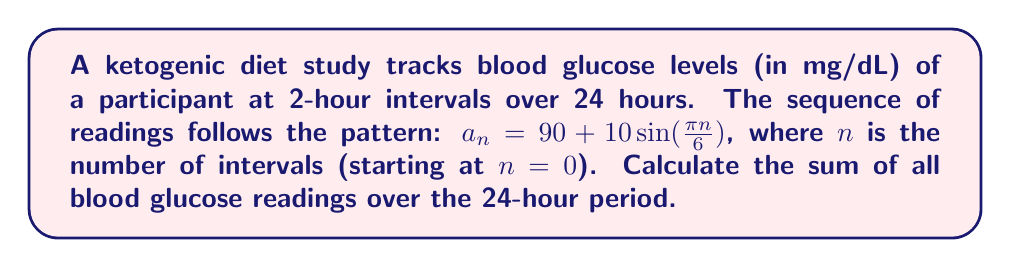Teach me how to tackle this problem. 1) First, we need to determine how many readings there are in 24 hours:
   24 hours / 2-hour intervals = 12 readings (plus the initial reading at n=0)
   So, we need to sum from n=0 to n=12

2) The formula for each reading is: $a_n = 90 + 10\sin(\frac{\pi n}{6})$

3) We need to calculate the sum: $\sum_{n=0}^{12} (90 + 10\sin(\frac{\pi n}{6}))$

4) This can be split into two sums:
   $\sum_{n=0}^{12} 90 + \sum_{n=0}^{12} 10\sin(\frac{\pi n}{6})$

5) The first sum is straightforward:
   $\sum_{n=0}^{12} 90 = 90 * 13 = 1170$

6) For the second sum, we can use the formula for the sum of sines:
   $\sum_{n=0}^{N} \sin(an) = \frac{\sin(\frac{aN}{2})\sin(\frac{a(N+1)}{2})}{\sin(\frac{a}{2})}$
   where $a = \frac{\pi}{6}$ and $N = 12$

7) Substituting these values:
   $10 * \frac{\sin(\frac{\pi * 12}{12})\sin(\frac{\pi * 13}{12})}{\sin(\frac{\pi}{12})}$
   $= 10 * \frac{\sin(\pi)\sin(\frac{13\pi}{12})}{\sin(\frac{\pi}{12})}$
   $= 10 * \frac{0 * \sin(\frac{13\pi}{12})}{\sin(\frac{\pi}{12})} = 0$

8) Therefore, the total sum is:
   $1170 + 0 = 1170$
Answer: 1170 mg/dL 